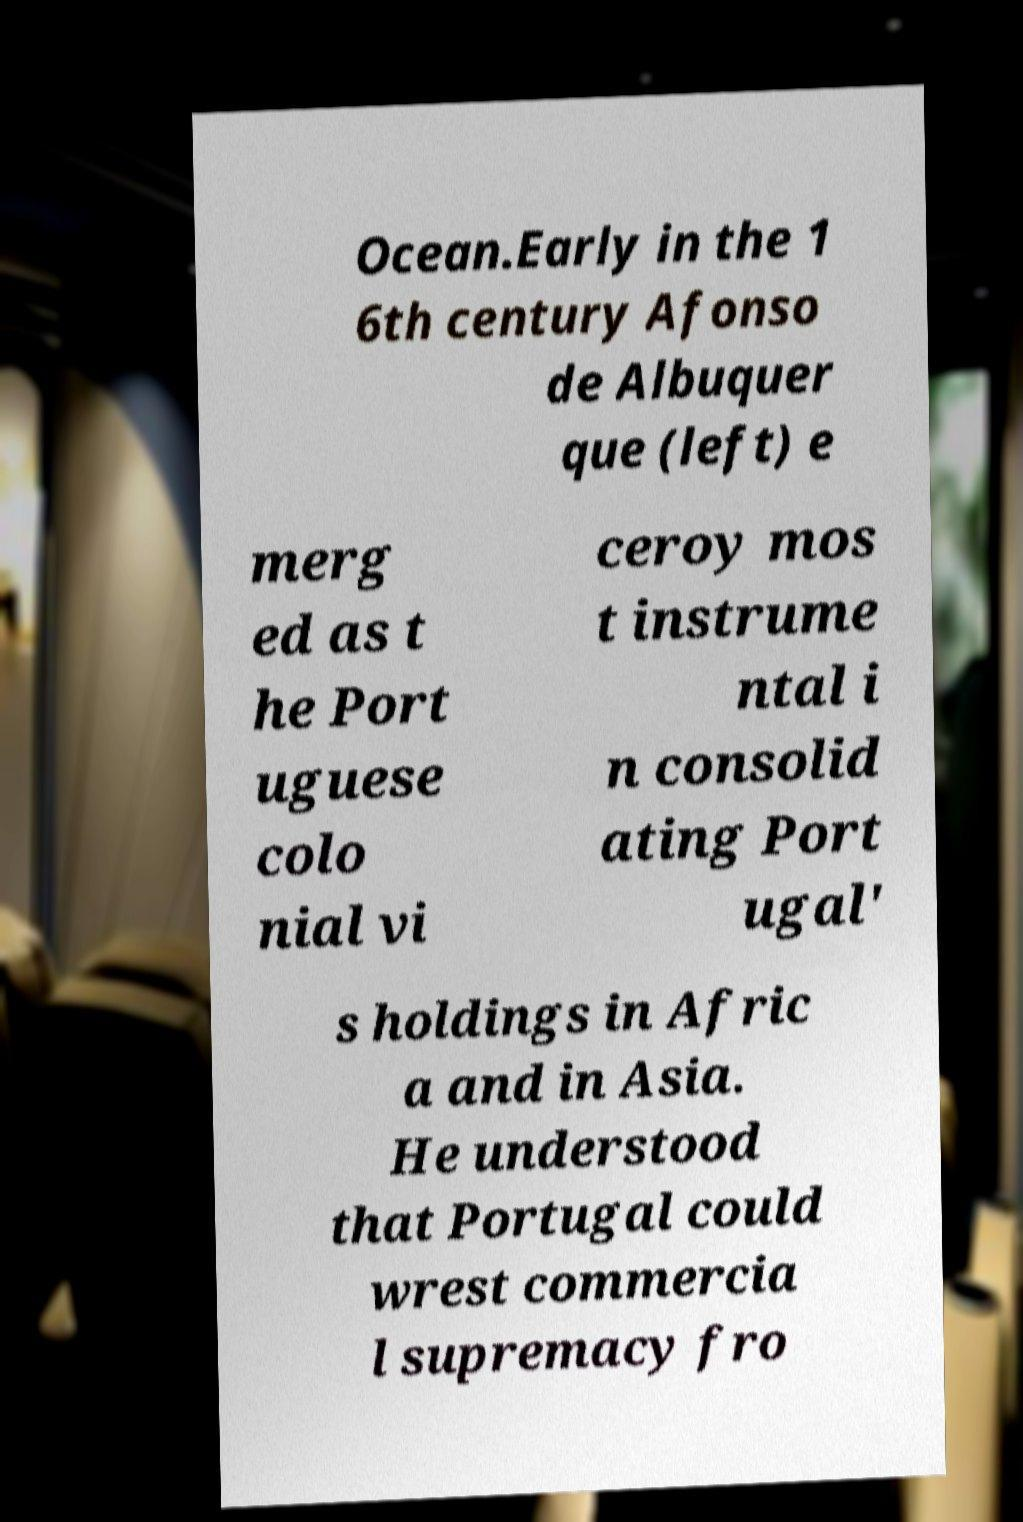There's text embedded in this image that I need extracted. Can you transcribe it verbatim? Ocean.Early in the 1 6th century Afonso de Albuquer que (left) e merg ed as t he Port uguese colo nial vi ceroy mos t instrume ntal i n consolid ating Port ugal' s holdings in Afric a and in Asia. He understood that Portugal could wrest commercia l supremacy fro 